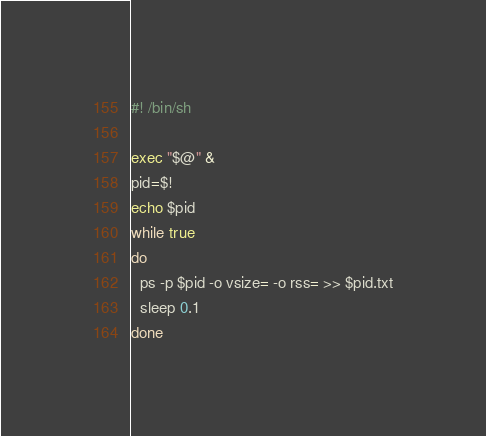Convert code to text. <code><loc_0><loc_0><loc_500><loc_500><_Bash_>#! /bin/sh

exec "$@" &
pid=$!
echo $pid 
while true
do
  ps -p $pid -o vsize= -o rss= >> $pid.txt
  sleep 0.1
done
</code> 